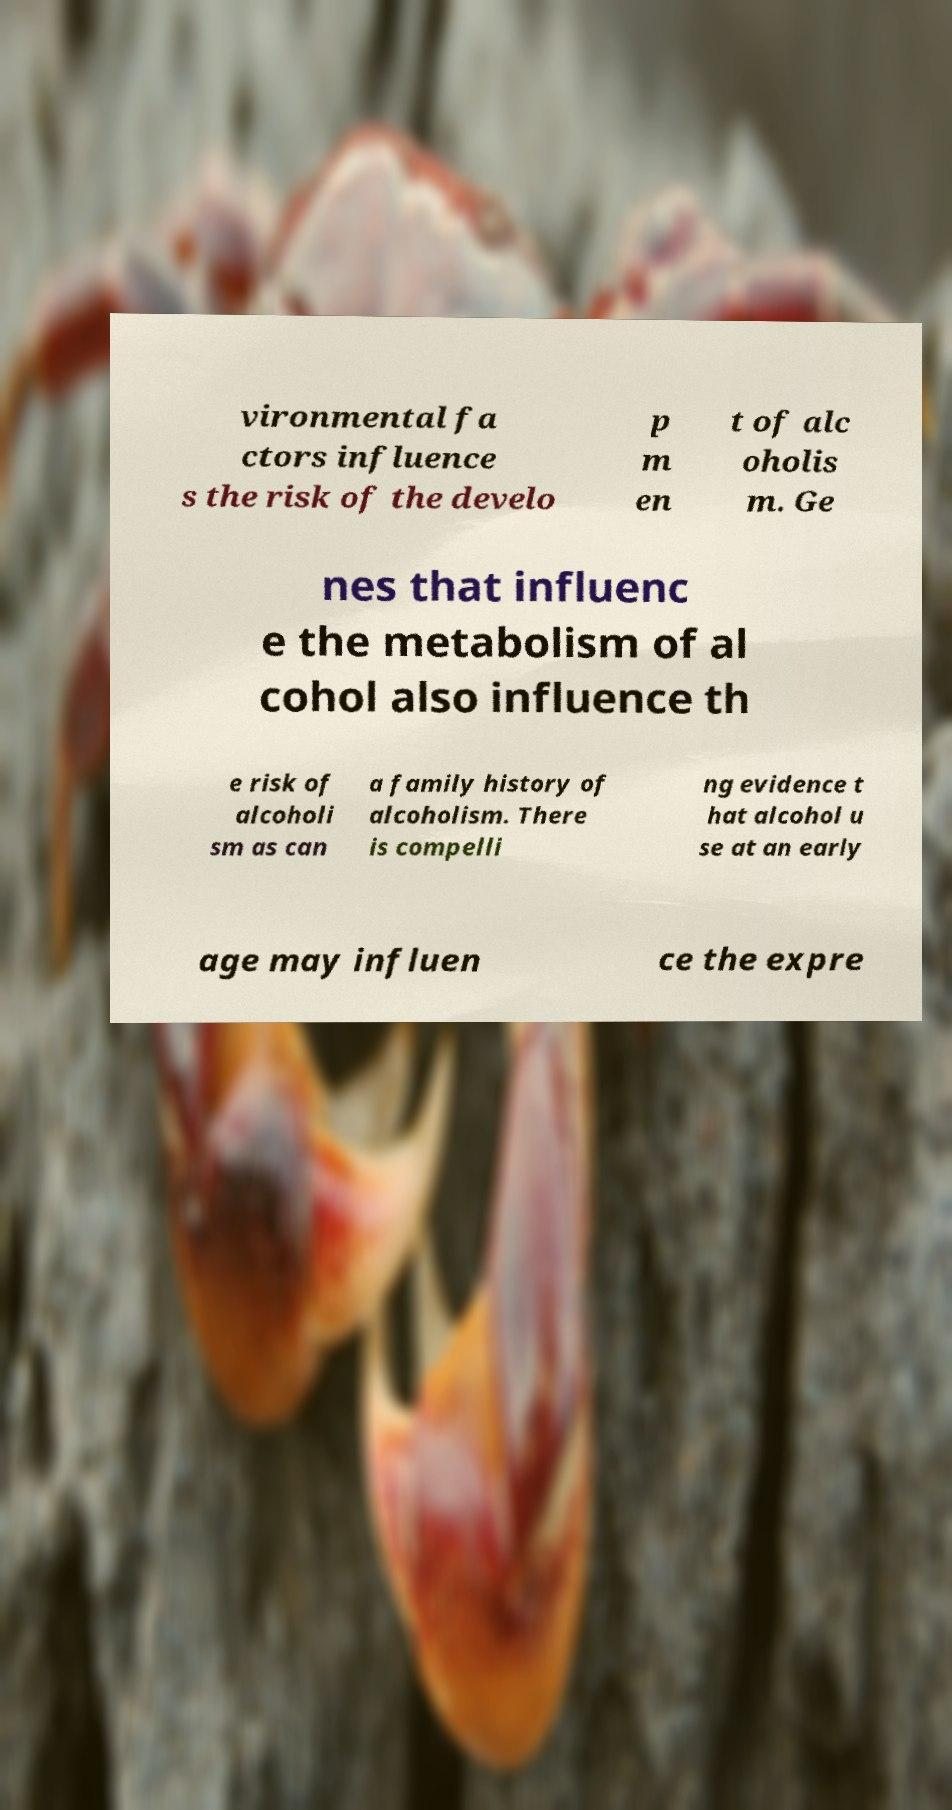Please read and relay the text visible in this image. What does it say? vironmental fa ctors influence s the risk of the develo p m en t of alc oholis m. Ge nes that influenc e the metabolism of al cohol also influence th e risk of alcoholi sm as can a family history of alcoholism. There is compelli ng evidence t hat alcohol u se at an early age may influen ce the expre 